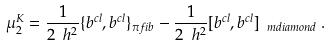<formula> <loc_0><loc_0><loc_500><loc_500>\mu ^ { K } _ { 2 } = \frac { 1 } { 2 \ h ^ { 2 } } \{ b ^ { c l } , b ^ { c l } \} _ { \pi f i b } - \frac { 1 } { 2 \ h ^ { 2 } } [ b ^ { c l } , b ^ { c l } ] _ { \ m d i a m o n d } \, .</formula> 